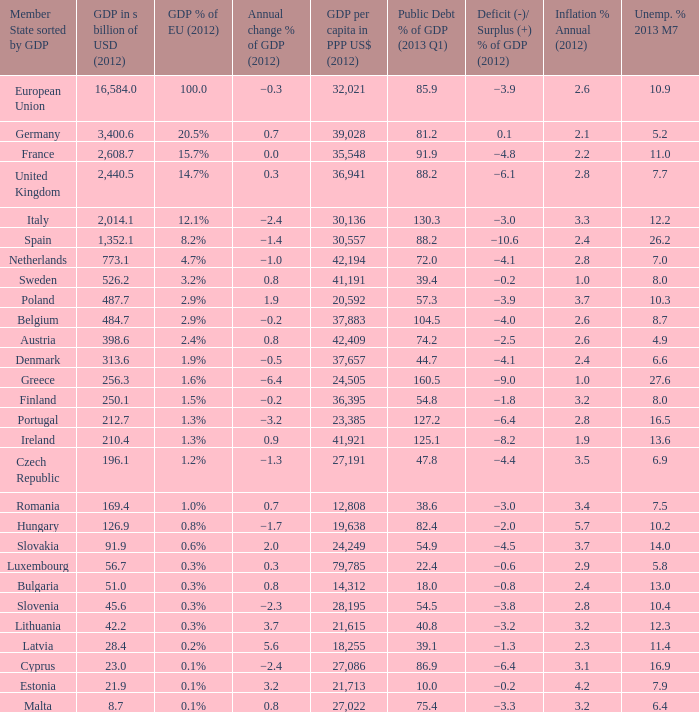What was the european union's gdp share in 2012 for the country with a gdp amounting to 25 1.6%. 